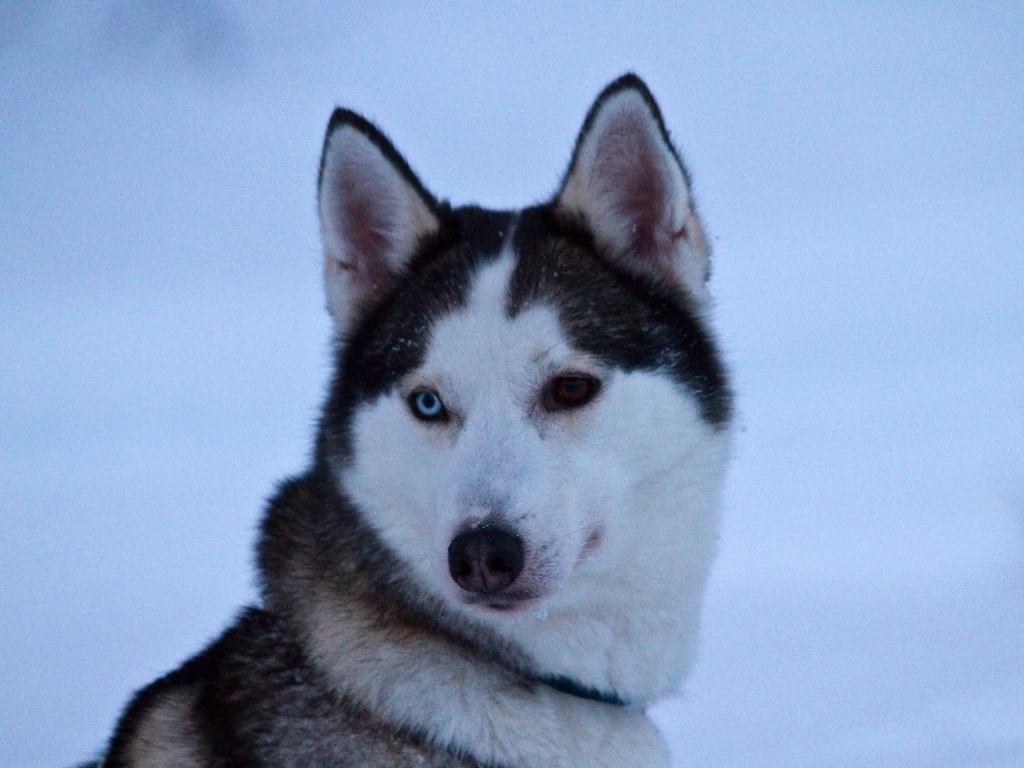Is the image heavily distorted? The image is not heavily distorted. It displays a clear and focused photograph of a dog, specifically a Siberian Husky, characterized by its thick fur coat, erect triangular ears, and distinctive markings. 